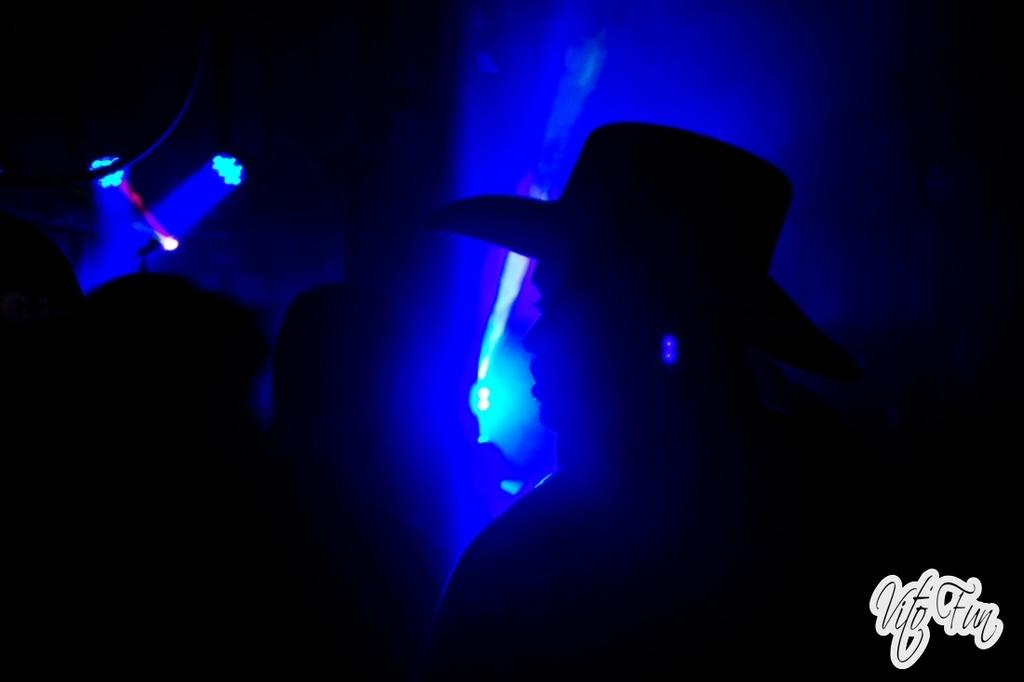How many people are in the image? There is a group of people in the image, but the exact number cannot be determined from the provided facts. What can be seen in the background of the image? There are lights in blue color in the background of the image. What type of dirt can be seen on the foot of the person in the image? There is no foot or dirt visible in the image; it only features a group of people and blue lights in the background. 